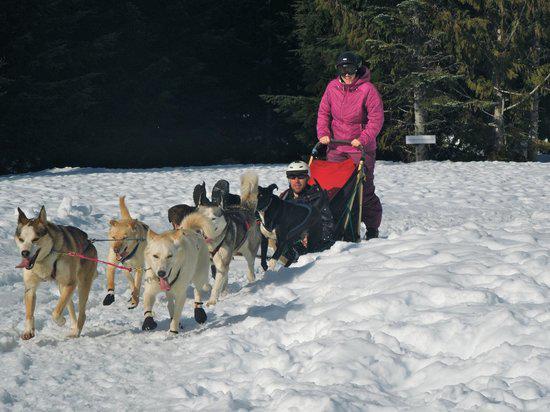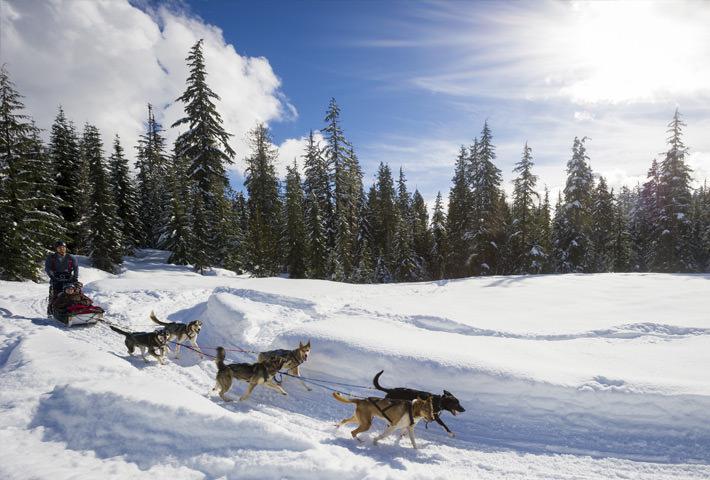The first image is the image on the left, the second image is the image on the right. For the images shown, is this caption "there is a dog sled team pulling a sled with one person standing and 3 people inside the sled" true? Answer yes or no. No. 